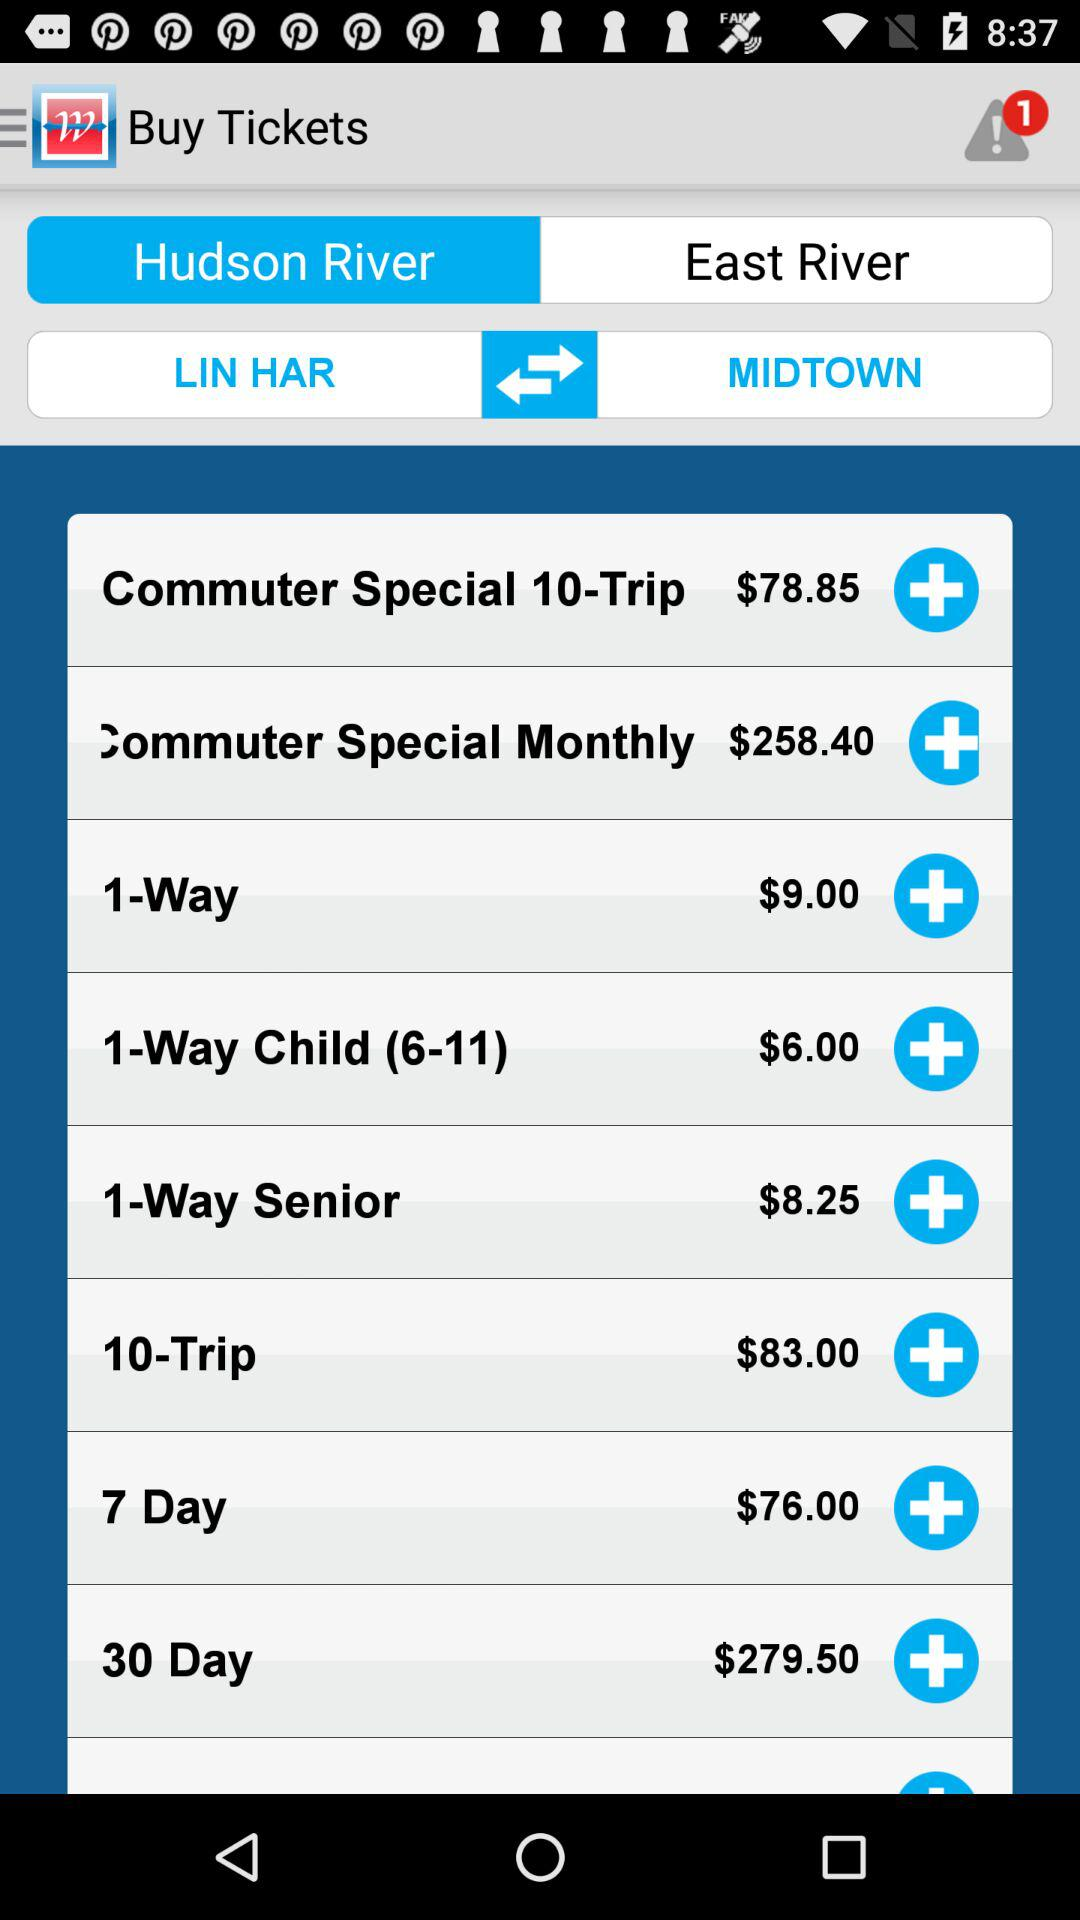Which option is selected? The selected option is "Hudson River". 